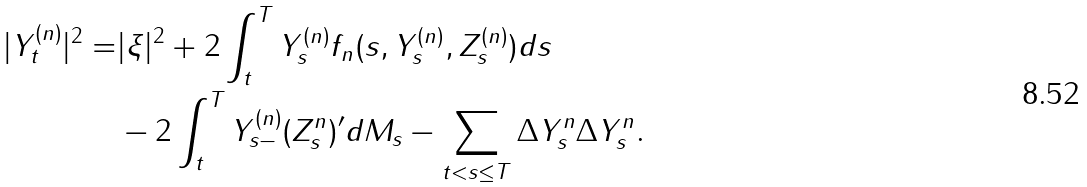Convert formula to latex. <formula><loc_0><loc_0><loc_500><loc_500>| Y ^ { ( n ) } _ { t } | ^ { 2 } = & | \xi | ^ { 2 } + 2 \int _ { t } ^ { T } Y ^ { ( n ) } _ { s } f _ { n } ( s , Y ^ { ( n ) } _ { s } , Z ^ { ( n ) } _ { s } ) d s \\ & - 2 \int _ { t } ^ { T } Y _ { s - } ^ { ( n ) } ( Z ^ { n } _ { s } ) ^ { \prime } d M _ { s } - \sum _ { t < s \leq T } \Delta Y _ { s } ^ { n } \Delta Y _ { s } ^ { n } .</formula> 